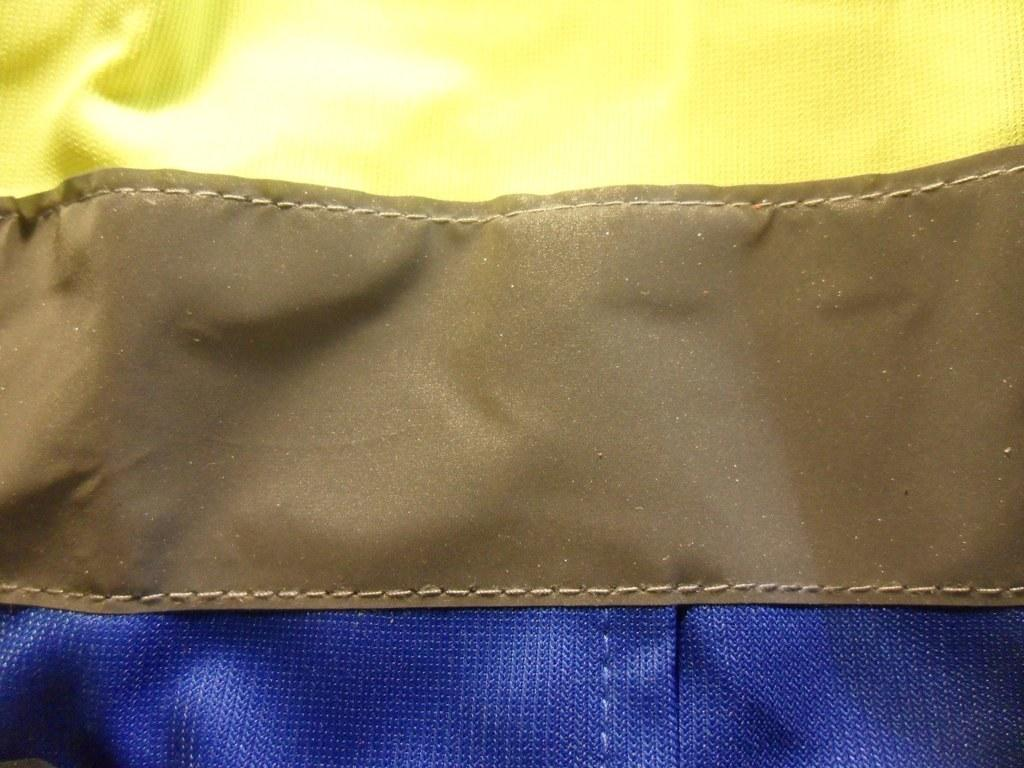What can be seen in the image related to clothing? There are clothes in the image. Can you describe any specific details about the clothes? The clothes have visible stitching. What type of smoke can be seen coming from the clothes in the image? There is no smoke present in the image; it only features clothes with visible stitching. 